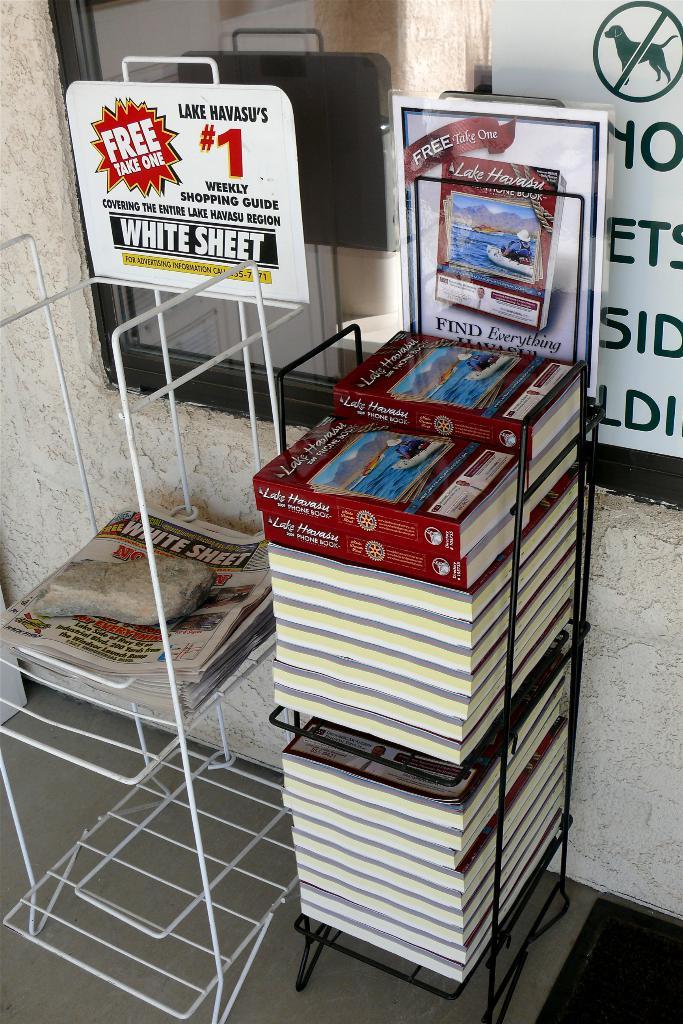What kind of magizine is  white sheet?
Provide a succinct answer. Weekly shopping guide. Is that a lake havasu shopping guide?
Give a very brief answer. Yes. 